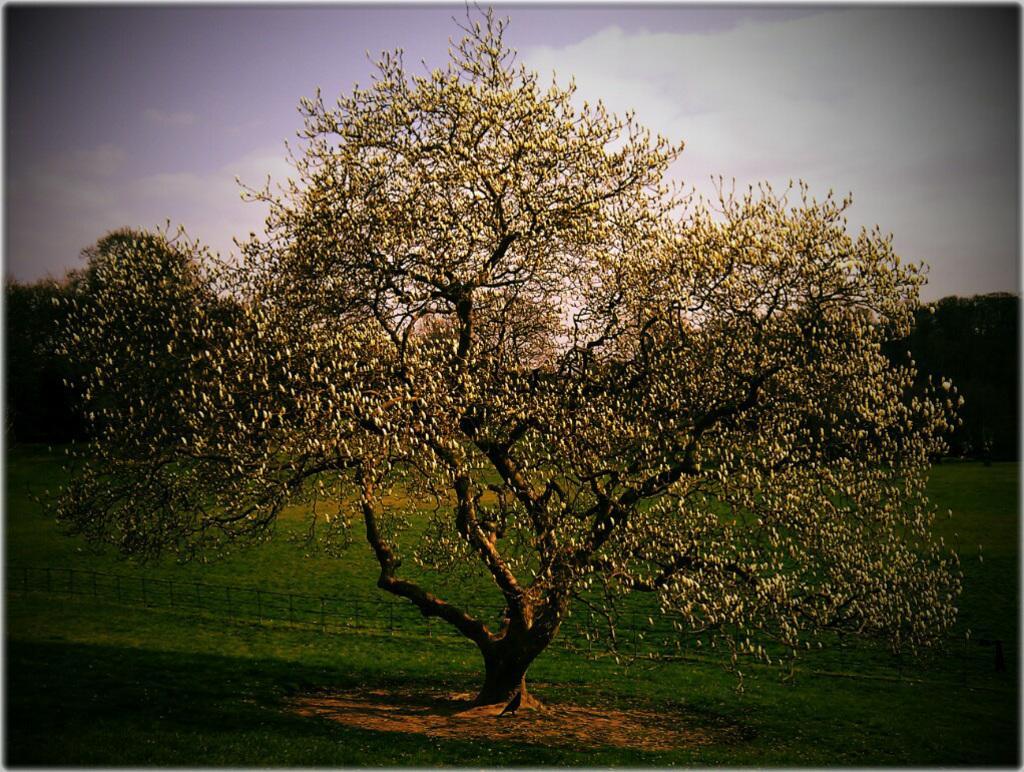Could you give a brief overview of what you see in this image? In this picture there are trees. In the foreground there is a fence and there is a bird under the tree. At the top there is sky and there are clouds. At the bottom there is grass. 